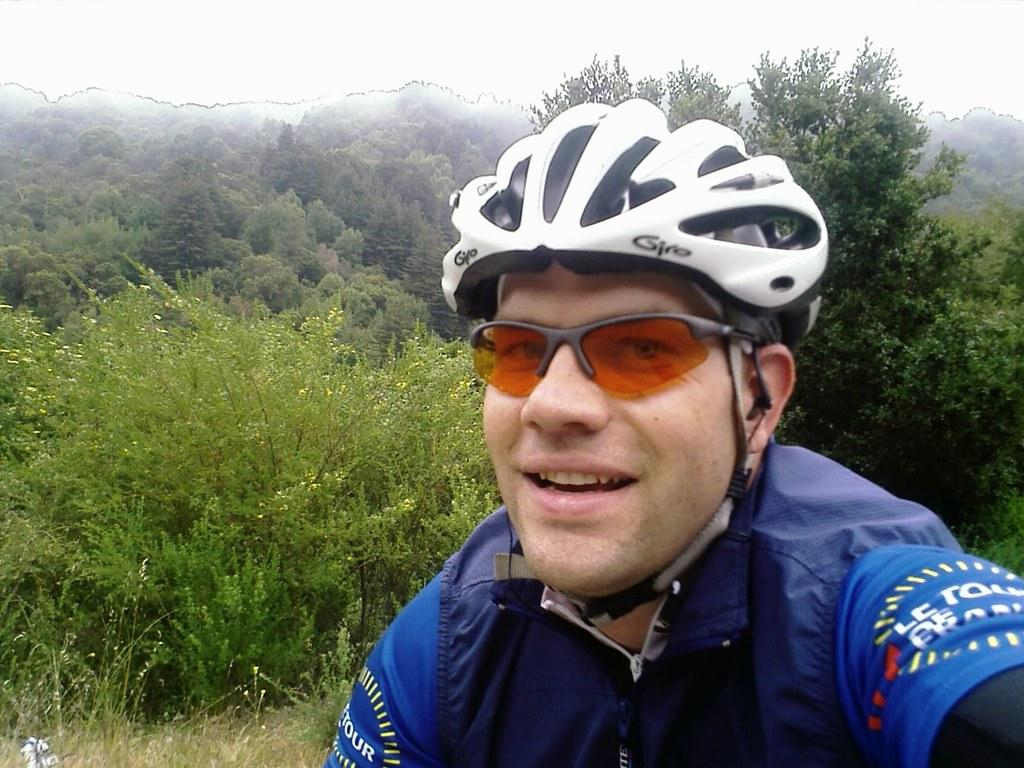Who or what is present in the image? There is a person in the image. What is the person wearing on their head? The person is wearing a helmet. What type of eyewear is the person wearing? The person is wearing spectacles. What can be seen in the background of the image? There are trees and the sky is visible in the background. What type of ring can be seen on the person's finger in the image? There is no ring visible on the person's finger in the image. 